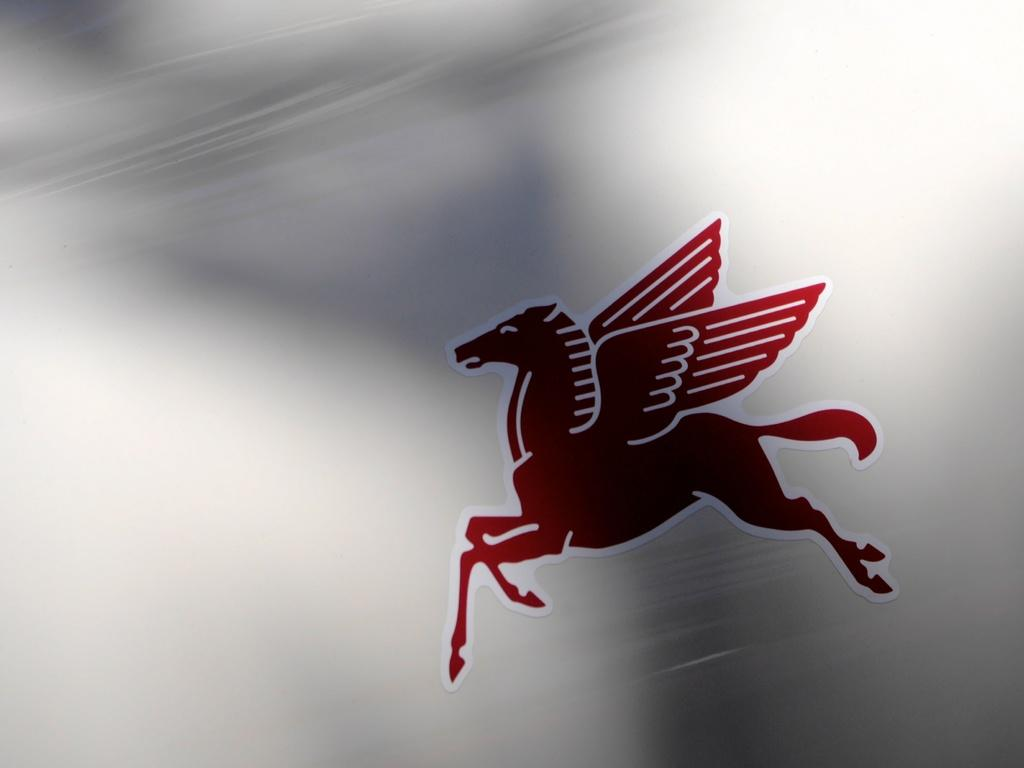What colors are used for the sticker in the image? The sticker in the image has red and white colors. What is the background color of the surface where the sticker is placed? The sticker is on a white color surface. What is depicted on the sticker? The sticker depicts an animal. How many flowers are present on the sticker in the image? There are no flowers depicted on the sticker in the image; it features an animal. Is there any money visible on the sticker in the image? There is no money depicted on the sticker in the image; it features an animal. 